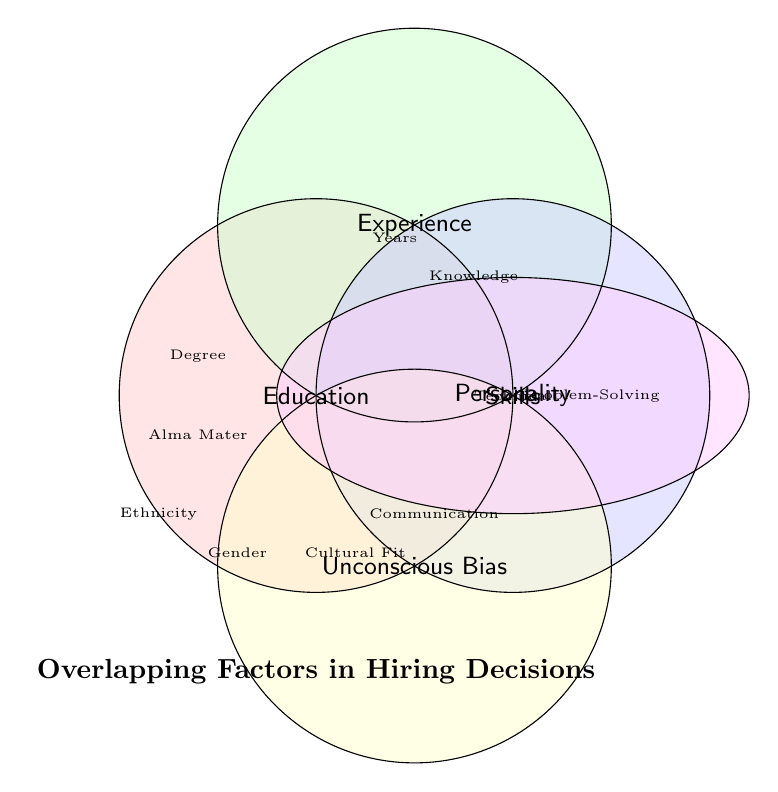How many main categories are depicted in the figure? Identify the distinct labeled areas in the Venn Diagram.
Answer: 5 What is the title of the Venn Diagram? Look at the text placed beneath the diagram.
Answer: Overlapping Factors in Hiring Decisions Which factors fall under the "Experience" category? Locate the labeled area for "Experience" and read the factors listed within or nearby.
Answer: Years, Industry Knowledge, Previous Job Titles Name one factor associated with "Unconscious Bias". Identify the area labeled "Unconscious Bias" and select one of the textual elements within or close by.
Answer: Gender (Acceptable alternatives: Age, Ethnicity, Name Association) Compare the factors listed under "Personality" and "Skills". How many factors are there in each category? Count the textual elements within the "Personality" and "Skills" areas respectively.
Answer: Personality: 3, Skills: 3 Which categories overlap, if any, based on visual representation? Examine areas where colors overlap and identify categories that share regions.
Answer: Multiple overlaps; details depend on the specific subset, e.g., Education & Experience Which category is uniquely represented by an ellipse shape? Identify the unique shape different from the circular representations and read the category label.
Answer: Skills Identify a factor that might be influenced by unconscious biases but is not listed under "Unconscious Bias". Consider social psychological contexts; factors under other categories might also be subject to bias. Select one such factor.
Answer: Relevant Degree How many educational factors are listed in the Venn Diagram? Find factors listed under the "Education" area and count them.
Answer: 3 Which category includes the "Communication Skills" factor? Observe the factor listing and read the associated category near it.
Answer: Personality 